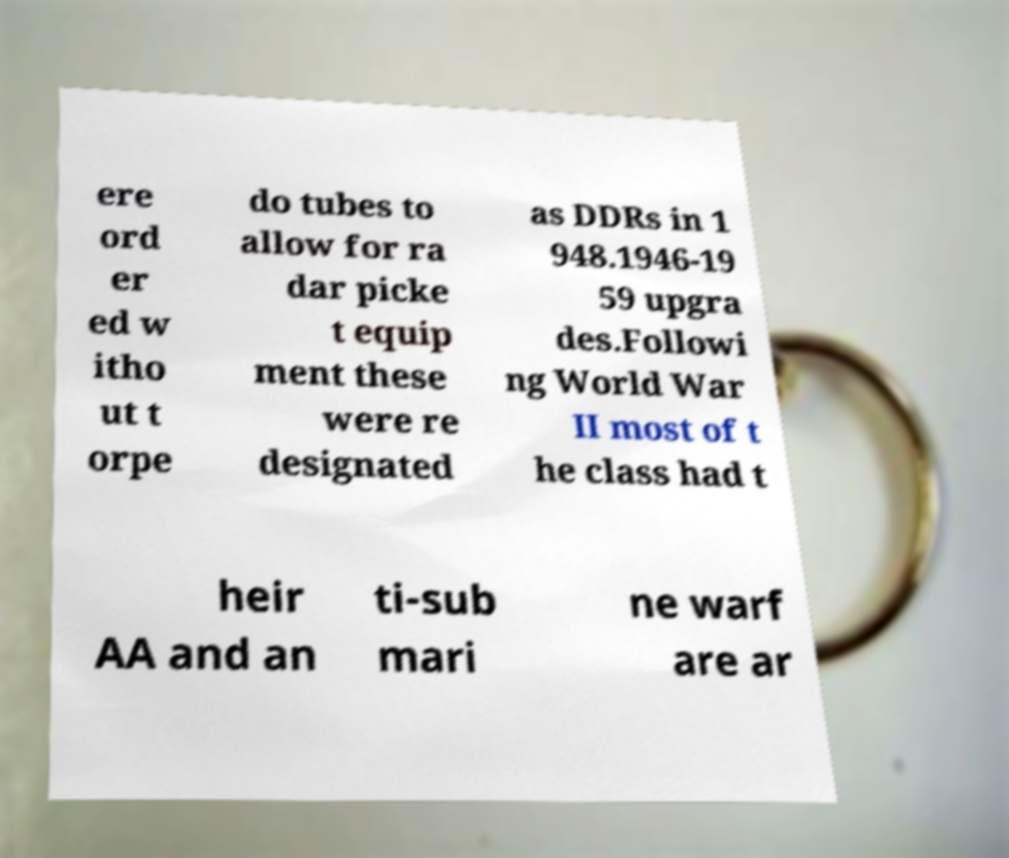Please read and relay the text visible in this image. What does it say? ere ord er ed w itho ut t orpe do tubes to allow for ra dar picke t equip ment these were re designated as DDRs in 1 948.1946-19 59 upgra des.Followi ng World War II most of t he class had t heir AA and an ti-sub mari ne warf are ar 